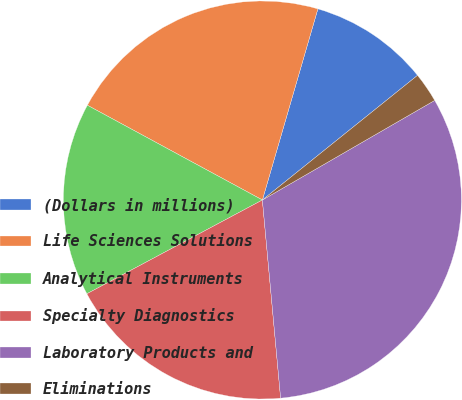Convert chart to OTSL. <chart><loc_0><loc_0><loc_500><loc_500><pie_chart><fcel>(Dollars in millions)<fcel>Life Sciences Solutions<fcel>Analytical Instruments<fcel>Specialty Diagnostics<fcel>Laboratory Products and<fcel>Eliminations<nl><fcel>9.73%<fcel>21.6%<fcel>15.71%<fcel>18.65%<fcel>31.88%<fcel>2.43%<nl></chart> 